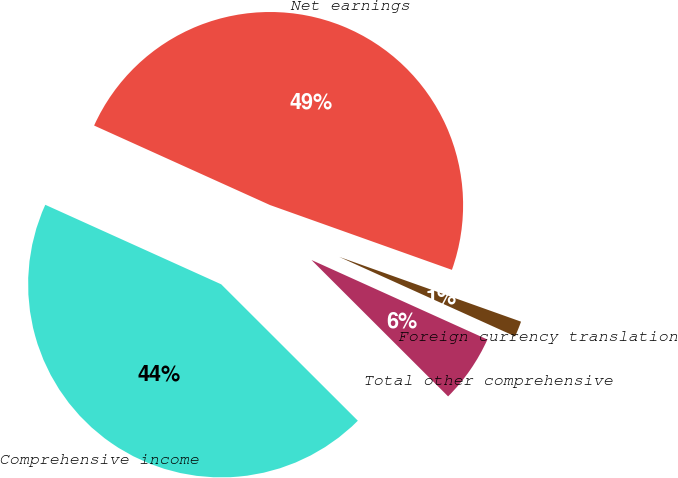Convert chart to OTSL. <chart><loc_0><loc_0><loc_500><loc_500><pie_chart><fcel>Net earnings<fcel>Foreign currency translation<fcel>Total other comprehensive<fcel>Comprehensive income<nl><fcel>48.69%<fcel>1.31%<fcel>5.73%<fcel>44.27%<nl></chart> 